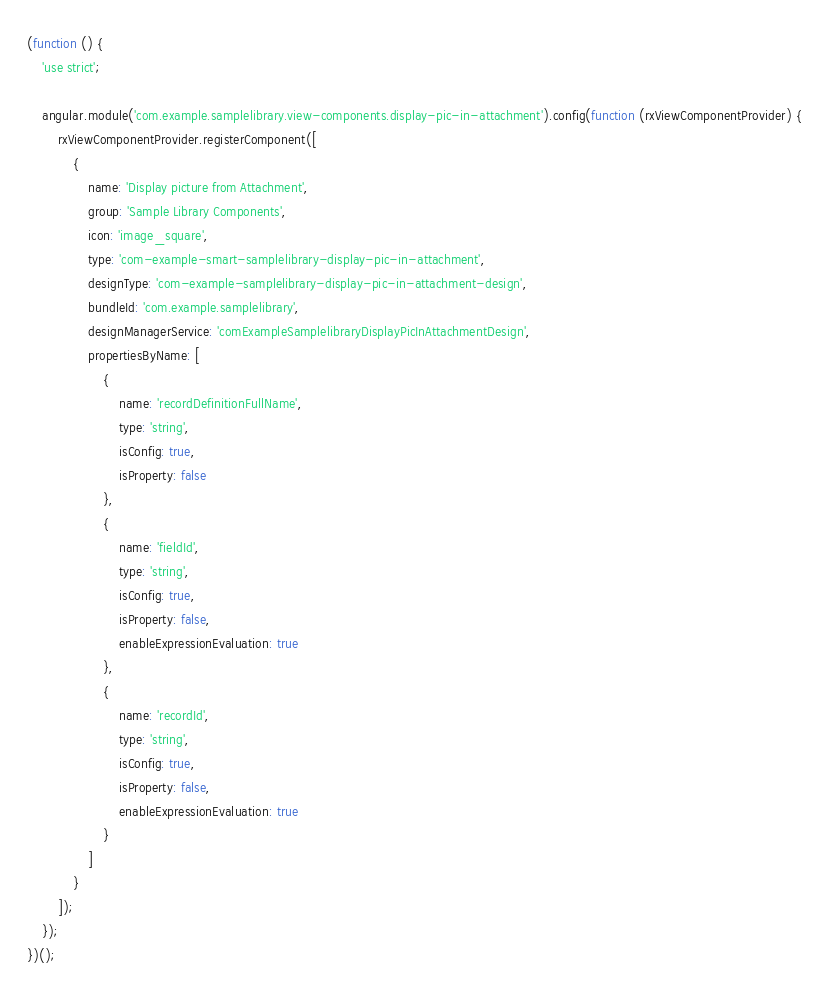Convert code to text. <code><loc_0><loc_0><loc_500><loc_500><_JavaScript_>(function () {
    'use strict';

    angular.module('com.example.samplelibrary.view-components.display-pic-in-attachment').config(function (rxViewComponentProvider) {
        rxViewComponentProvider.registerComponent([
            {
                name: 'Display picture from Attachment',
                group: 'Sample Library Components',
                icon: 'image_square',
                type: 'com-example-smart-samplelibrary-display-pic-in-attachment',
                designType: 'com-example-samplelibrary-display-pic-in-attachment-design',
                bundleId: 'com.example.samplelibrary',
                designManagerService: 'comExampleSamplelibraryDisplayPicInAttachmentDesign',
                propertiesByName: [
                    {
                        name: 'recordDefinitionFullName',
                        type: 'string',
                        isConfig: true,
                        isProperty: false
                    },
                    {
                        name: 'fieldId',
                        type: 'string',
                        isConfig: true,
                        isProperty: false,
                        enableExpressionEvaluation: true
                    },
                    {
                        name: 'recordId',
                        type: 'string',
                        isConfig: true,
                        isProperty: false,
                        enableExpressionEvaluation: true
                    }
                ]
            }
        ]);
    });
})();</code> 